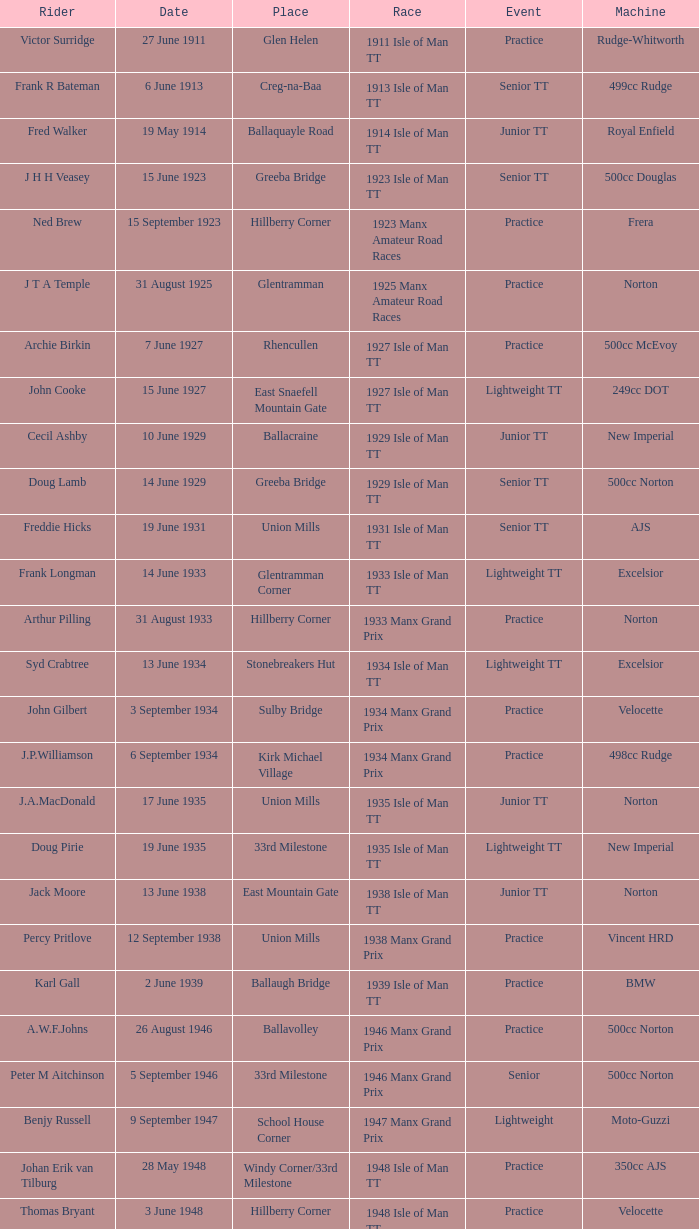What machine did Kenneth E. Herbert ride? 499cc Norton. 